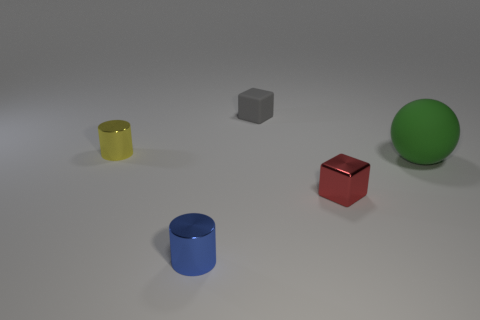There is a metal object that is both in front of the large rubber object and left of the small red block; what shape is it?
Your answer should be very brief. Cylinder. How many blue things have the same material as the small gray thing?
Your answer should be compact. 0. Is the number of gray blocks to the left of the blue object less than the number of large brown rubber spheres?
Your response must be concise. No. Are there any green rubber spheres that are right of the small metallic cylinder behind the large green ball?
Make the answer very short. Yes. Is there any other thing that is the same shape as the green rubber object?
Ensure brevity in your answer.  No. Do the gray thing and the red metallic block have the same size?
Your answer should be very brief. Yes. There is a small object to the left of the metal cylinder to the right of the tiny yellow shiny object left of the tiny gray rubber thing; what is its material?
Make the answer very short. Metal. Are there the same number of tiny shiny cylinders that are behind the blue cylinder and tiny yellow cylinders?
Provide a short and direct response. Yes. Is there any other thing that has the same size as the green thing?
Ensure brevity in your answer.  No. What number of things are big metal cylinders or small gray rubber blocks?
Keep it short and to the point. 1. 